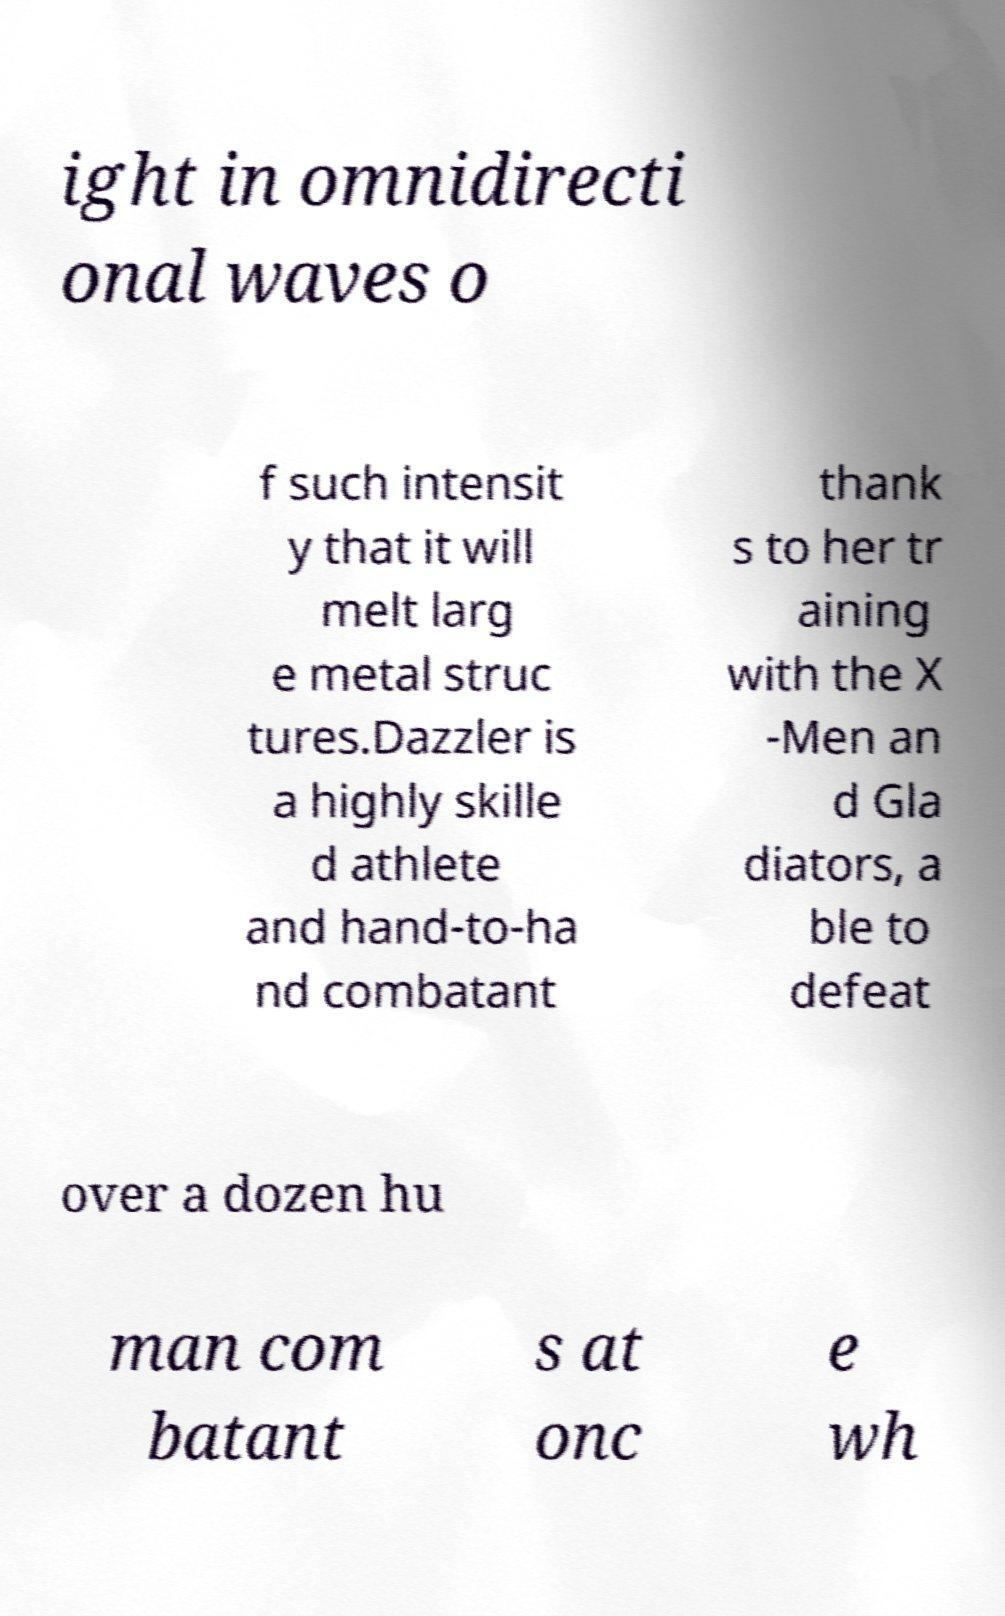For documentation purposes, I need the text within this image transcribed. Could you provide that? ight in omnidirecti onal waves o f such intensit y that it will melt larg e metal struc tures.Dazzler is a highly skille d athlete and hand-to-ha nd combatant thank s to her tr aining with the X -Men an d Gla diators, a ble to defeat over a dozen hu man com batant s at onc e wh 